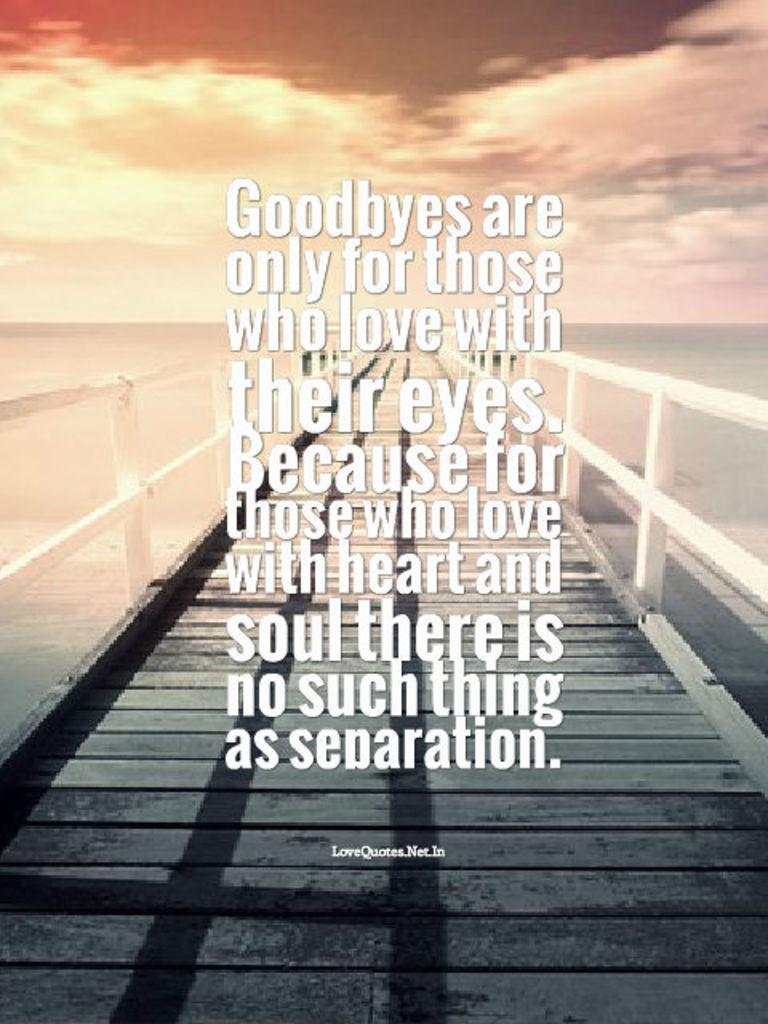What is the main feature of the image? There is a large water body in the image. What structure can be seen crossing the water body? There is a bridge in the image. What can be seen above the water body and bridge? The sky is visible in the image. How would you describe the weather based on the sky in the image? The sky appears to be cloudy in the image. Are there any words or letters present in the image? Yes, there is text present in the image. Can you tell me how many snakes are slithering around the kettle in the image? There are no snakes or kettles present in the image. 